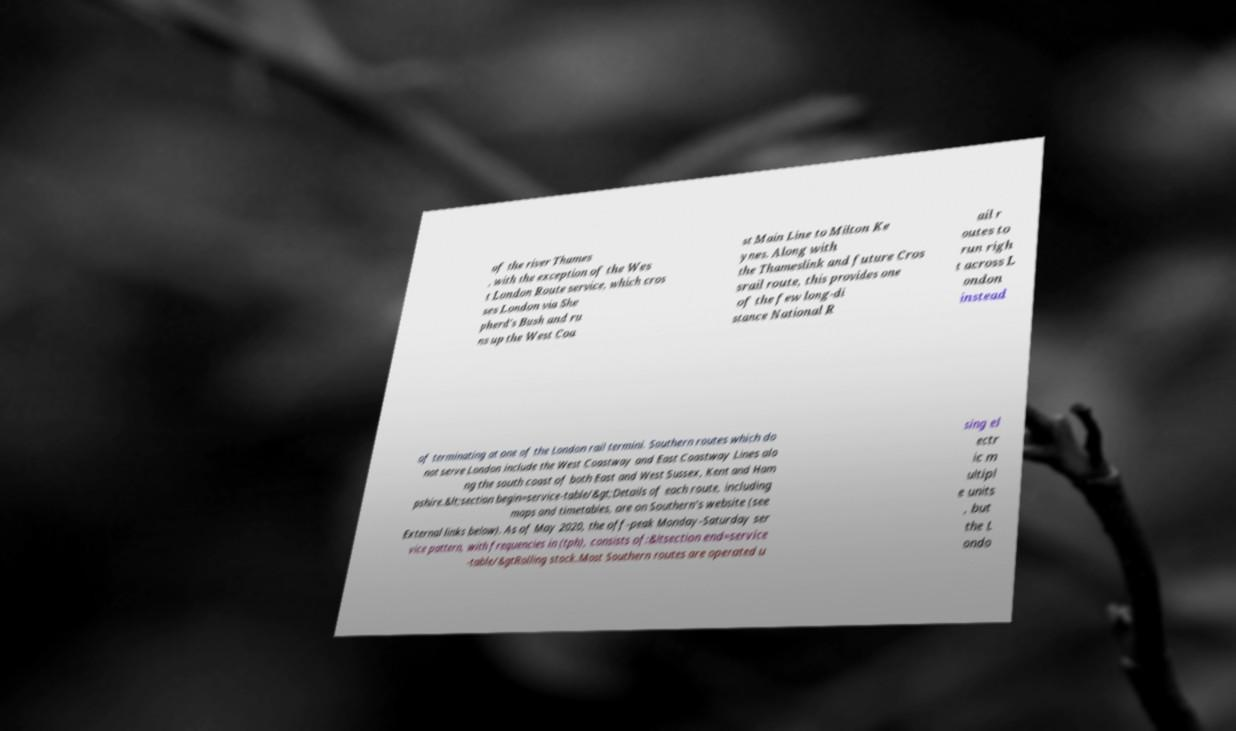Can you accurately transcribe the text from the provided image for me? of the river Thames , with the exception of the Wes t London Route service, which cros ses London via She pherd's Bush and ru ns up the West Coa st Main Line to Milton Ke ynes. Along with the Thameslink and future Cros srail route, this provides one of the few long-di stance National R ail r outes to run righ t across L ondon instead of terminating at one of the London rail termini. Southern routes which do not serve London include the West Coastway and East Coastway Lines alo ng the south coast of both East and West Sussex, Kent and Ham pshire.&lt;section begin=service-table/&gt;Details of each route, including maps and timetables, are on Southern's website (see External links below). As of May 2020, the off-peak Monday-Saturday ser vice pattern, with frequencies in (tph), consists of:&ltsection end=service -table/&gtRolling stock.Most Southern routes are operated u sing el ectr ic m ultipl e units , but the L ondo 